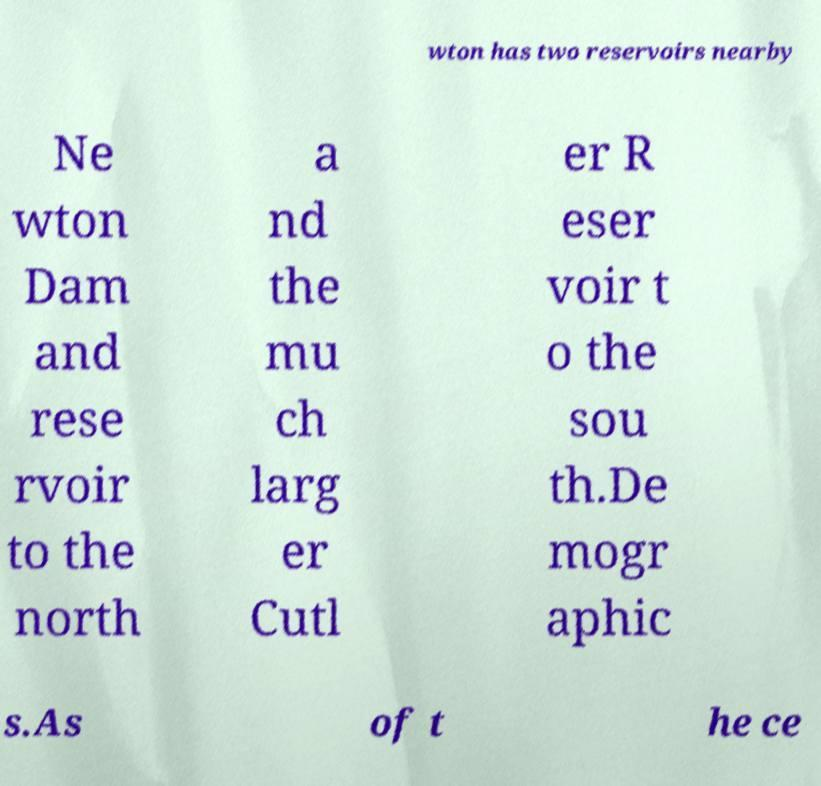There's text embedded in this image that I need extracted. Can you transcribe it verbatim? wton has two reservoirs nearby Ne wton Dam and rese rvoir to the north a nd the mu ch larg er Cutl er R eser voir t o the sou th.De mogr aphic s.As of t he ce 